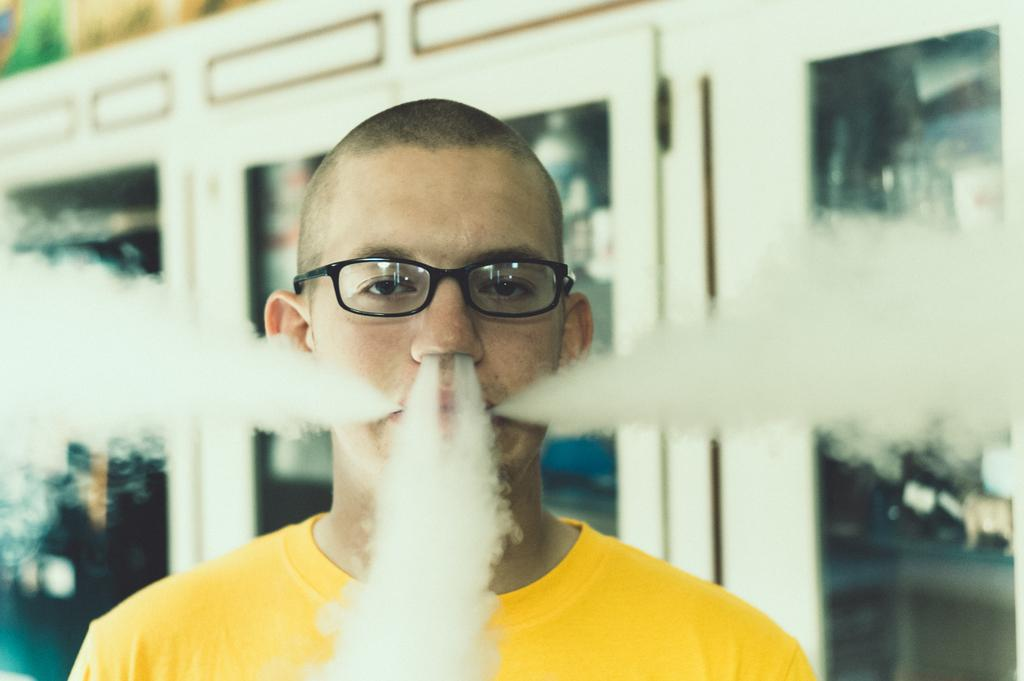What is present in the image? There is a person in the image. What is happening to the person in the image? Smoke is coming out from the person's nostrils and ears. What can be seen in the background of the image? There are glass doors in the background of the image. What type of pet can be seen in the image? There is no pet visible in the image. What place is the person in the image visiting? The image does not provide any information about the person's location or destination. 